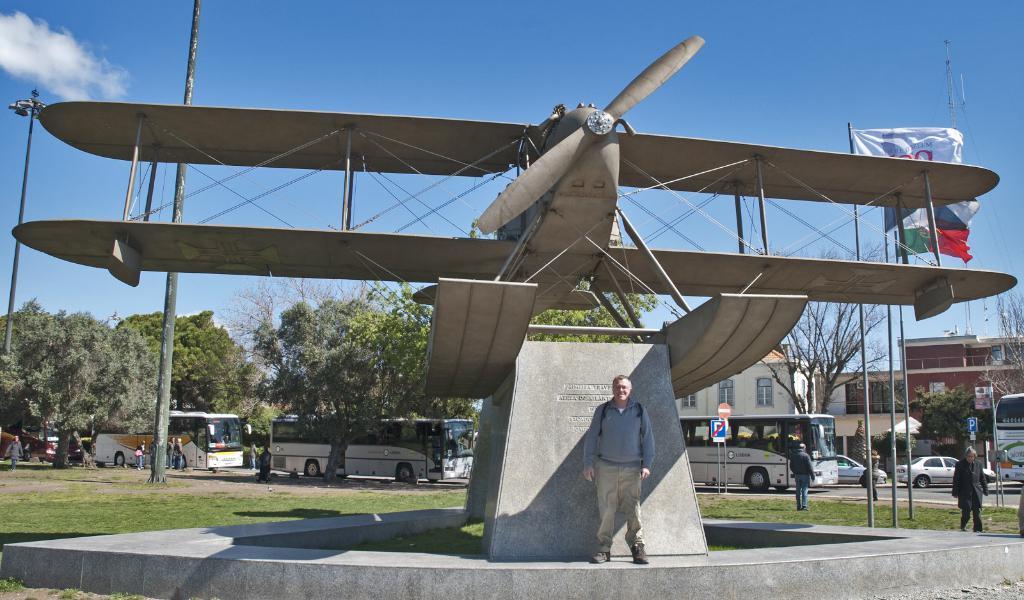How would you summarize this image in a sentence or two? In the center of the image we can see a sculpture and there are people. We can see vehicles on the road. In the background there are trees, buildings and sky. We can see poles. 